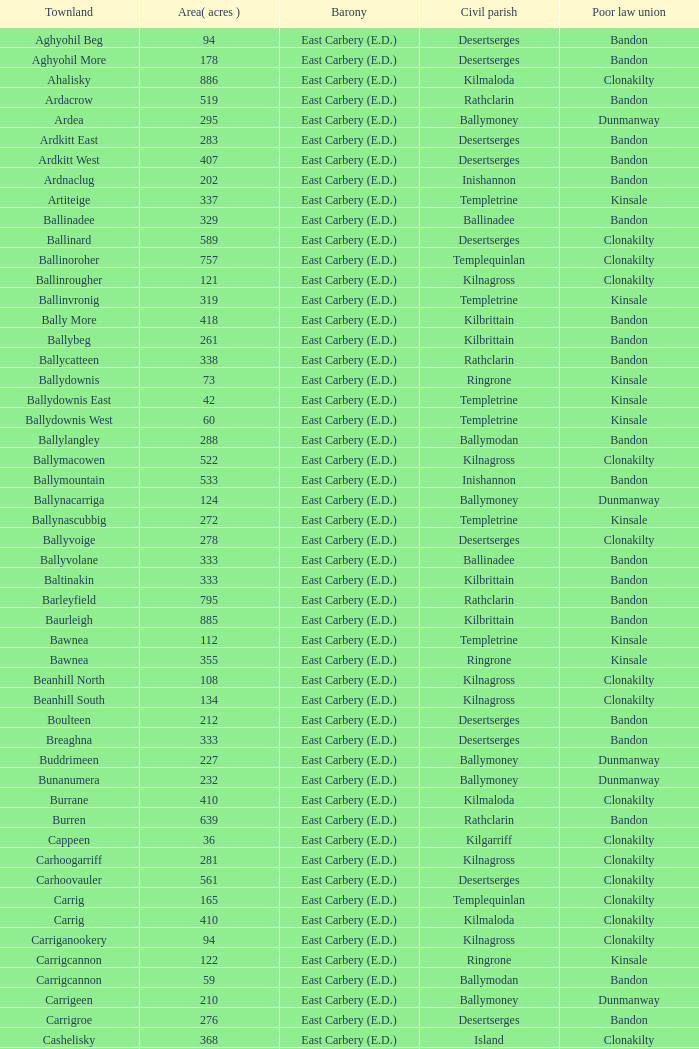What is the maximum area (in acres) of the Knockacullen townland? 381.0. 